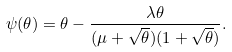<formula> <loc_0><loc_0><loc_500><loc_500>\psi ( \theta ) = \theta - \frac { \lambda \theta } { ( \mu + \sqrt { \theta } ) ( 1 + \sqrt { \theta } ) } .</formula> 